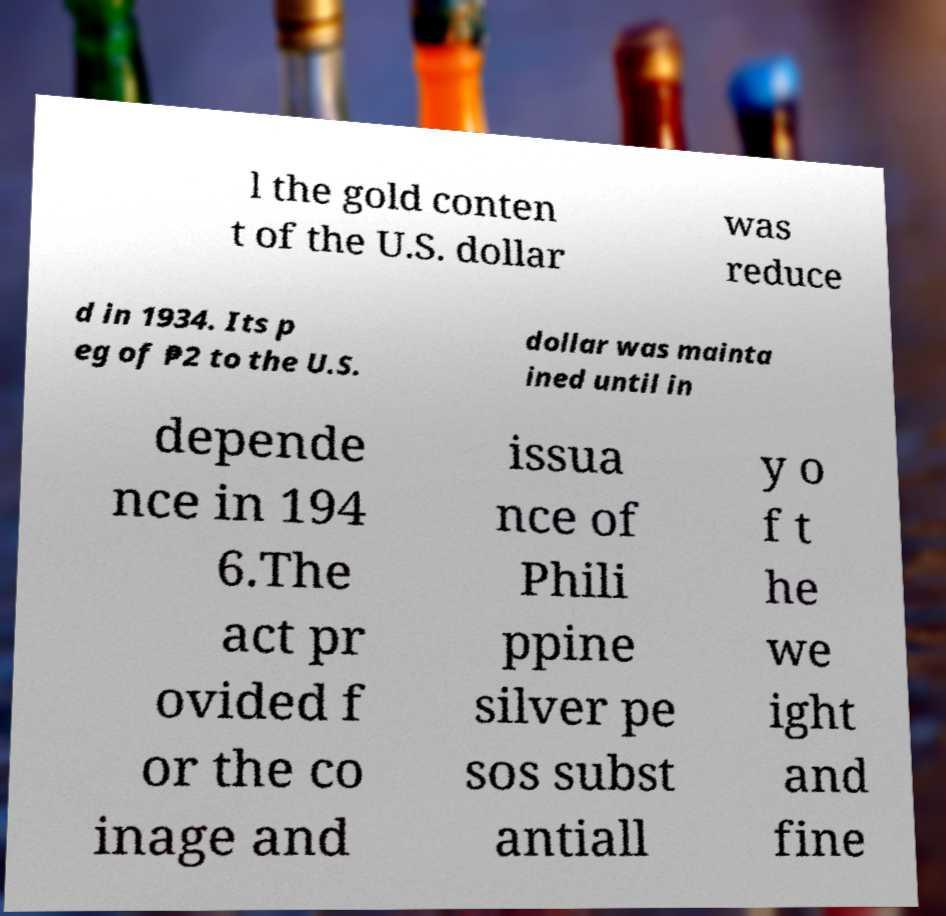Could you extract and type out the text from this image? l the gold conten t of the U.S. dollar was reduce d in 1934. Its p eg of ₱2 to the U.S. dollar was mainta ined until in depende nce in 194 6.The act pr ovided f or the co inage and issua nce of Phili ppine silver pe sos subst antiall y o f t he we ight and fine 